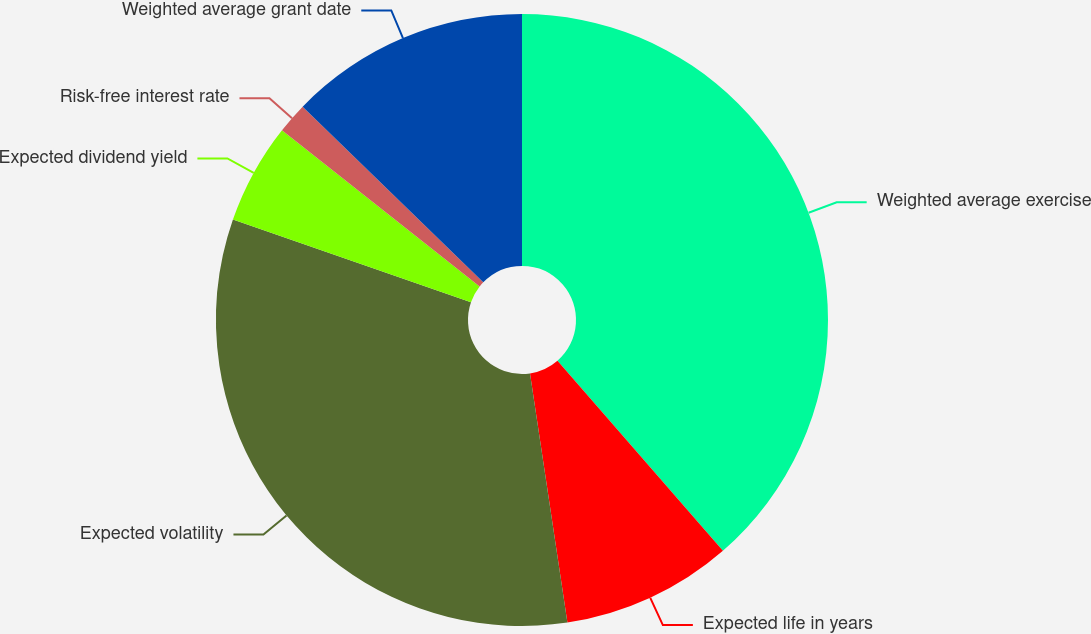Convert chart to OTSL. <chart><loc_0><loc_0><loc_500><loc_500><pie_chart><fcel>Weighted average exercise<fcel>Expected life in years<fcel>Expected volatility<fcel>Expected dividend yield<fcel>Risk-free interest rate<fcel>Weighted average grant date<nl><fcel>38.6%<fcel>9.03%<fcel>32.69%<fcel>5.33%<fcel>1.63%<fcel>12.72%<nl></chart> 